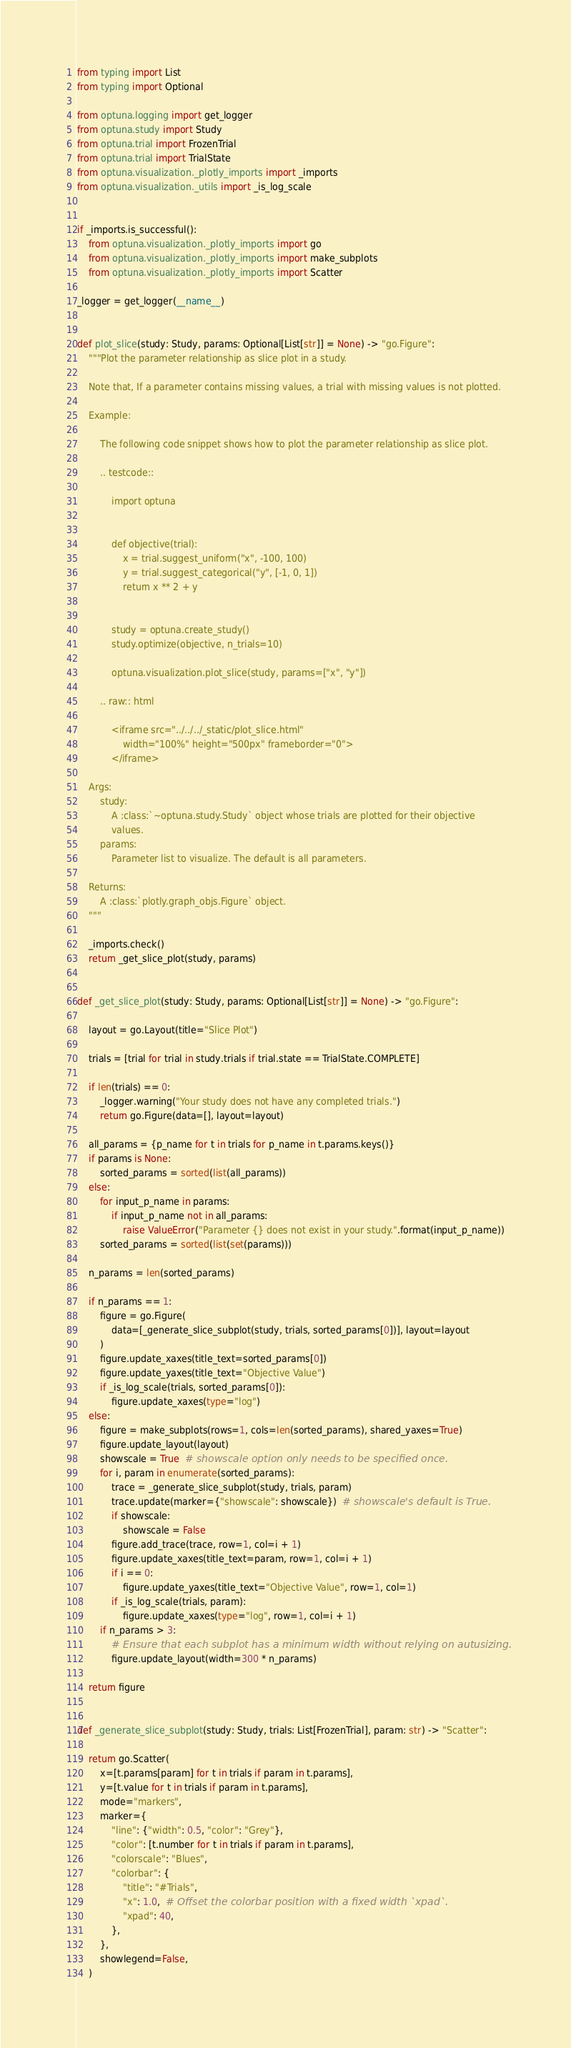Convert code to text. <code><loc_0><loc_0><loc_500><loc_500><_Python_>from typing import List
from typing import Optional

from optuna.logging import get_logger
from optuna.study import Study
from optuna.trial import FrozenTrial
from optuna.trial import TrialState
from optuna.visualization._plotly_imports import _imports
from optuna.visualization._utils import _is_log_scale


if _imports.is_successful():
    from optuna.visualization._plotly_imports import go
    from optuna.visualization._plotly_imports import make_subplots
    from optuna.visualization._plotly_imports import Scatter

_logger = get_logger(__name__)


def plot_slice(study: Study, params: Optional[List[str]] = None) -> "go.Figure":
    """Plot the parameter relationship as slice plot in a study.

    Note that, If a parameter contains missing values, a trial with missing values is not plotted.

    Example:

        The following code snippet shows how to plot the parameter relationship as slice plot.

        .. testcode::

            import optuna


            def objective(trial):
                x = trial.suggest_uniform("x", -100, 100)
                y = trial.suggest_categorical("y", [-1, 0, 1])
                return x ** 2 + y


            study = optuna.create_study()
            study.optimize(objective, n_trials=10)

            optuna.visualization.plot_slice(study, params=["x", "y"])

        .. raw:: html

            <iframe src="../../../_static/plot_slice.html"
                width="100%" height="500px" frameborder="0">
            </iframe>

    Args:
        study:
            A :class:`~optuna.study.Study` object whose trials are plotted for their objective
            values.
        params:
            Parameter list to visualize. The default is all parameters.

    Returns:
        A :class:`plotly.graph_objs.Figure` object.
    """

    _imports.check()
    return _get_slice_plot(study, params)


def _get_slice_plot(study: Study, params: Optional[List[str]] = None) -> "go.Figure":

    layout = go.Layout(title="Slice Plot")

    trials = [trial for trial in study.trials if trial.state == TrialState.COMPLETE]

    if len(trials) == 0:
        _logger.warning("Your study does not have any completed trials.")
        return go.Figure(data=[], layout=layout)

    all_params = {p_name for t in trials for p_name in t.params.keys()}
    if params is None:
        sorted_params = sorted(list(all_params))
    else:
        for input_p_name in params:
            if input_p_name not in all_params:
                raise ValueError("Parameter {} does not exist in your study.".format(input_p_name))
        sorted_params = sorted(list(set(params)))

    n_params = len(sorted_params)

    if n_params == 1:
        figure = go.Figure(
            data=[_generate_slice_subplot(study, trials, sorted_params[0])], layout=layout
        )
        figure.update_xaxes(title_text=sorted_params[0])
        figure.update_yaxes(title_text="Objective Value")
        if _is_log_scale(trials, sorted_params[0]):
            figure.update_xaxes(type="log")
    else:
        figure = make_subplots(rows=1, cols=len(sorted_params), shared_yaxes=True)
        figure.update_layout(layout)
        showscale = True  # showscale option only needs to be specified once.
        for i, param in enumerate(sorted_params):
            trace = _generate_slice_subplot(study, trials, param)
            trace.update(marker={"showscale": showscale})  # showscale's default is True.
            if showscale:
                showscale = False
            figure.add_trace(trace, row=1, col=i + 1)
            figure.update_xaxes(title_text=param, row=1, col=i + 1)
            if i == 0:
                figure.update_yaxes(title_text="Objective Value", row=1, col=1)
            if _is_log_scale(trials, param):
                figure.update_xaxes(type="log", row=1, col=i + 1)
        if n_params > 3:
            # Ensure that each subplot has a minimum width without relying on autusizing.
            figure.update_layout(width=300 * n_params)

    return figure


def _generate_slice_subplot(study: Study, trials: List[FrozenTrial], param: str) -> "Scatter":

    return go.Scatter(
        x=[t.params[param] for t in trials if param in t.params],
        y=[t.value for t in trials if param in t.params],
        mode="markers",
        marker={
            "line": {"width": 0.5, "color": "Grey"},
            "color": [t.number for t in trials if param in t.params],
            "colorscale": "Blues",
            "colorbar": {
                "title": "#Trials",
                "x": 1.0,  # Offset the colorbar position with a fixed width `xpad`.
                "xpad": 40,
            },
        },
        showlegend=False,
    )
</code> 